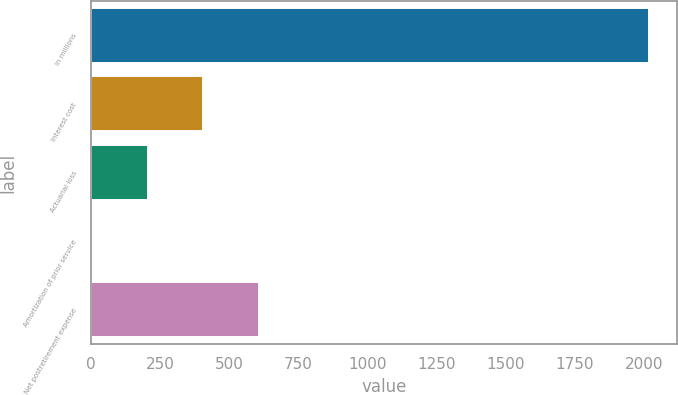Convert chart. <chart><loc_0><loc_0><loc_500><loc_500><bar_chart><fcel>In millions<fcel>Interest cost<fcel>Actuarial loss<fcel>Amortization of prior service<fcel>Net postretirement expense<nl><fcel>2017<fcel>405.8<fcel>204.4<fcel>3<fcel>607.2<nl></chart> 